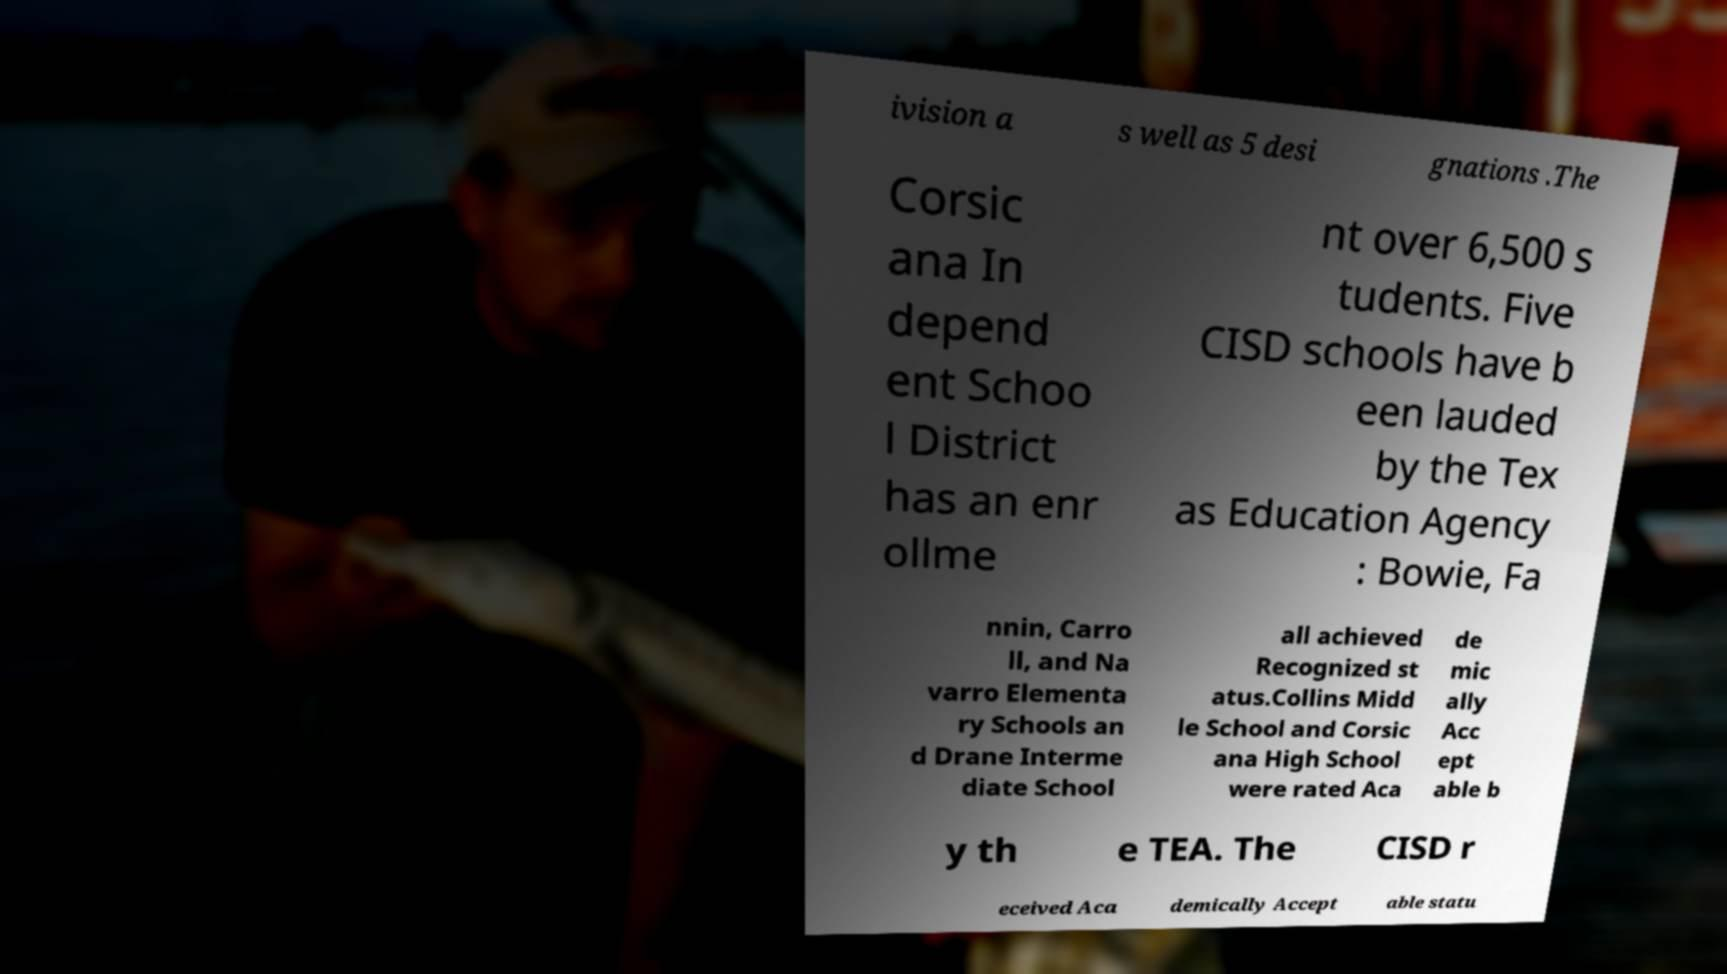Could you assist in decoding the text presented in this image and type it out clearly? ivision a s well as 5 desi gnations .The Corsic ana In depend ent Schoo l District has an enr ollme nt over 6,500 s tudents. Five CISD schools have b een lauded by the Tex as Education Agency : Bowie, Fa nnin, Carro ll, and Na varro Elementa ry Schools an d Drane Interme diate School all achieved Recognized st atus.Collins Midd le School and Corsic ana High School were rated Aca de mic ally Acc ept able b y th e TEA. The CISD r eceived Aca demically Accept able statu 